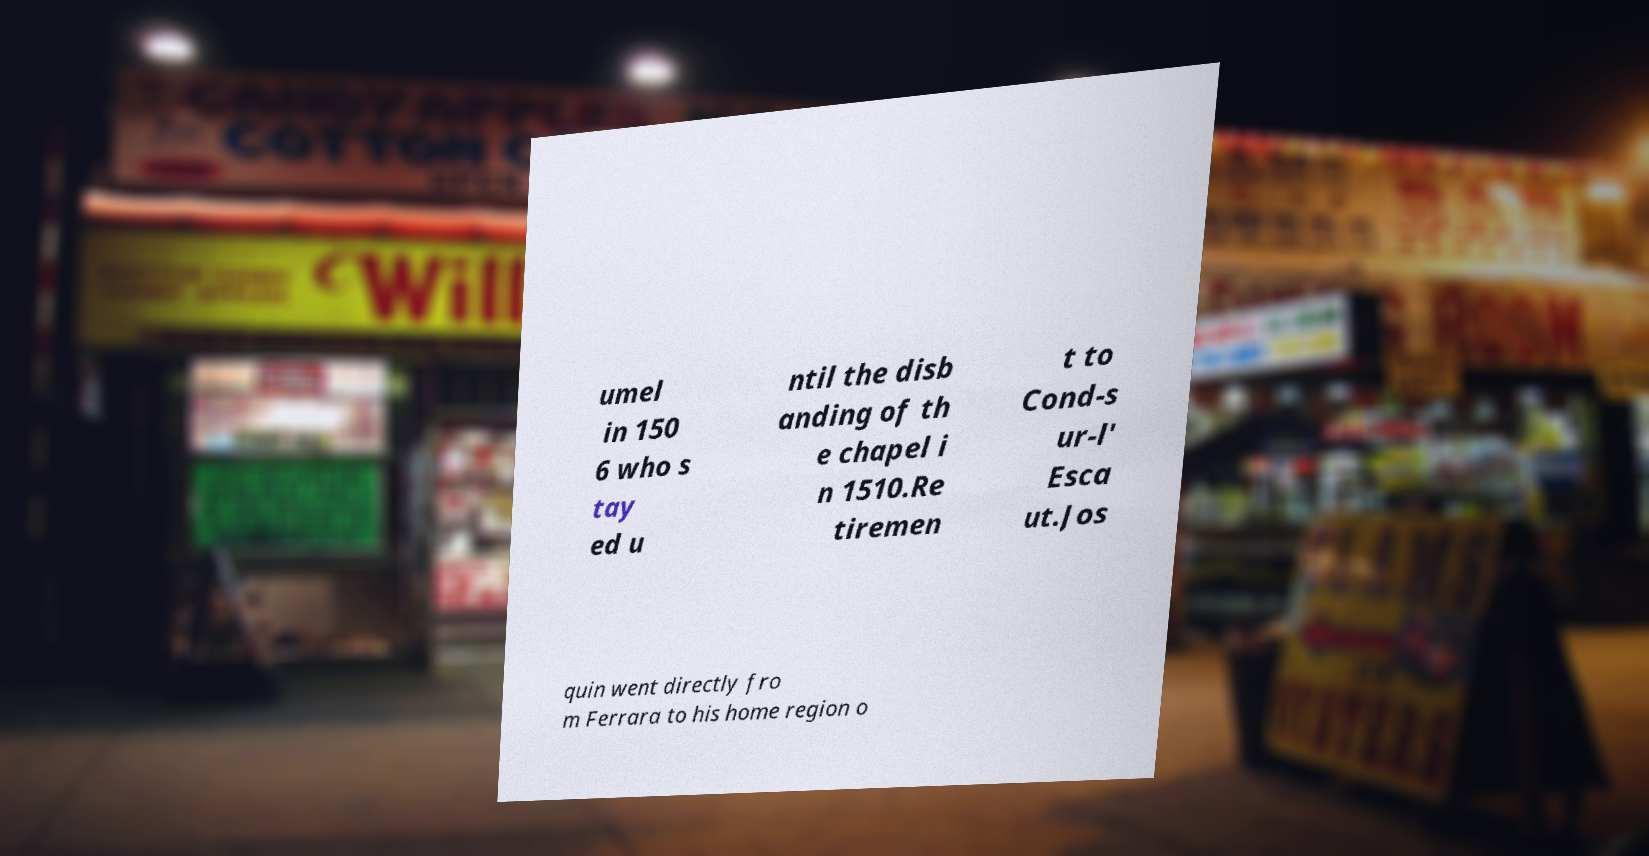Can you read and provide the text displayed in the image?This photo seems to have some interesting text. Can you extract and type it out for me? umel in 150 6 who s tay ed u ntil the disb anding of th e chapel i n 1510.Re tiremen t to Cond-s ur-l' Esca ut.Jos quin went directly fro m Ferrara to his home region o 